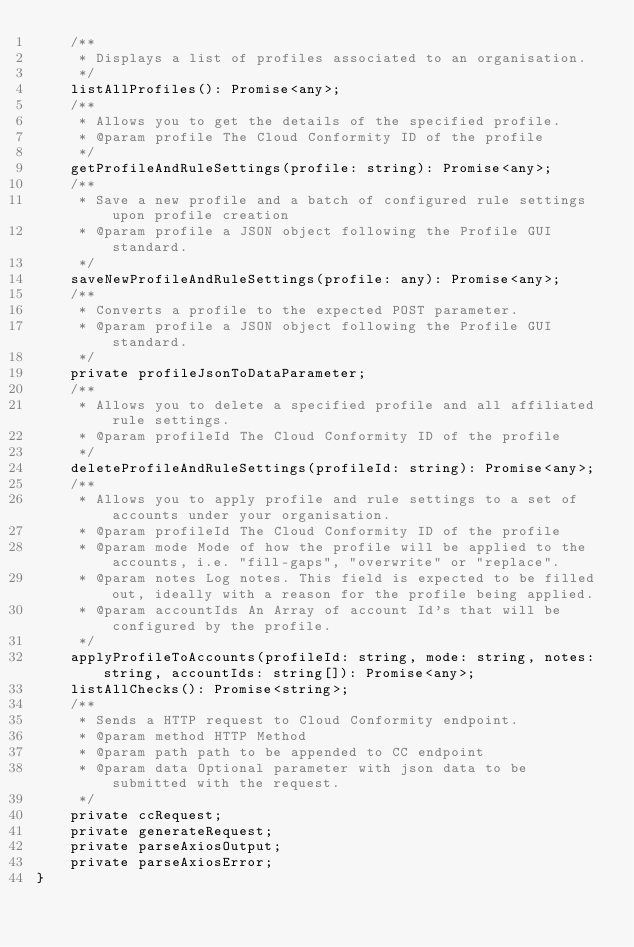<code> <loc_0><loc_0><loc_500><loc_500><_TypeScript_>    /**
     * Displays a list of profiles associated to an organisation.
     */
    listAllProfiles(): Promise<any>;
    /**
     * Allows you to get the details of the specified profile.
     * @param profile The Cloud Conformity ID of the profile
     */
    getProfileAndRuleSettings(profile: string): Promise<any>;
    /**
     * Save a new profile and a batch of configured rule settings upon profile creation
     * @param profile a JSON object following the Profile GUI standard.
     */
    saveNewProfileAndRuleSettings(profile: any): Promise<any>;
    /**
     * Converts a profile to the expected POST parameter.
     * @param profile a JSON object following the Profile GUI standard.
     */
    private profileJsonToDataParameter;
    /**
     * Allows you to delete a specified profile and all affiliated rule settings.
     * @param profileId The Cloud Conformity ID of the profile
     */
    deleteProfileAndRuleSettings(profileId: string): Promise<any>;
    /**
     * Allows you to apply profile and rule settings to a set of accounts under your organisation.
     * @param profileId The Cloud Conformity ID of the profile
     * @param mode Mode of how the profile will be applied to the accounts, i.e. "fill-gaps", "overwrite" or "replace".
     * @param notes Log notes. This field is expected to be filled out, ideally with a reason for the profile being applied.
     * @param accountIds An Array of account Id's that will be configured by the profile.
     */
    applyProfileToAccounts(profileId: string, mode: string, notes: string, accountIds: string[]): Promise<any>;
    listAllChecks(): Promise<string>;
    /**
     * Sends a HTTP request to Cloud Conformity endpoint.
     * @param method HTTP Method
     * @param path path to be appended to CC endpoint
     * @param data Optional parameter with json data to be submitted with the request.
     */
    private ccRequest;
    private generateRequest;
    private parseAxiosOutput;
    private parseAxiosError;
}
</code> 